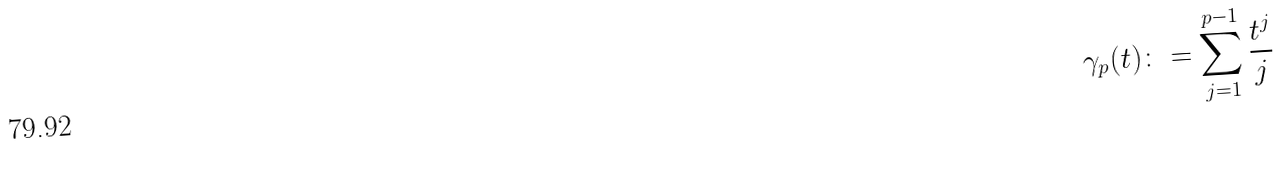Convert formula to latex. <formula><loc_0><loc_0><loc_500><loc_500>\gamma _ { p } ( t ) \colon = \sum _ { j = 1 } ^ { p - 1 } \frac { t ^ { j } } { j }</formula> 